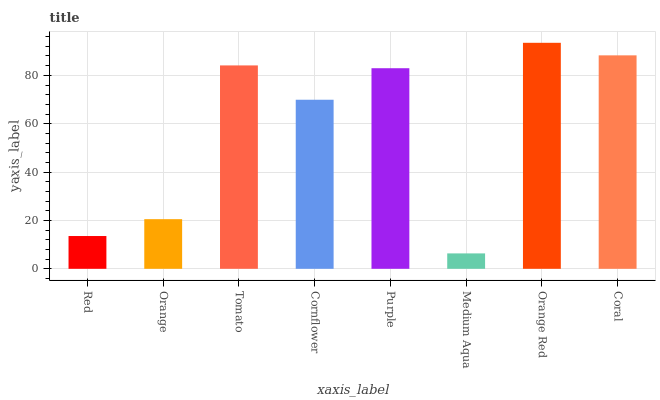Is Medium Aqua the minimum?
Answer yes or no. Yes. Is Orange Red the maximum?
Answer yes or no. Yes. Is Orange the minimum?
Answer yes or no. No. Is Orange the maximum?
Answer yes or no. No. Is Orange greater than Red?
Answer yes or no. Yes. Is Red less than Orange?
Answer yes or no. Yes. Is Red greater than Orange?
Answer yes or no. No. Is Orange less than Red?
Answer yes or no. No. Is Purple the high median?
Answer yes or no. Yes. Is Cornflower the low median?
Answer yes or no. Yes. Is Cornflower the high median?
Answer yes or no. No. Is Coral the low median?
Answer yes or no. No. 